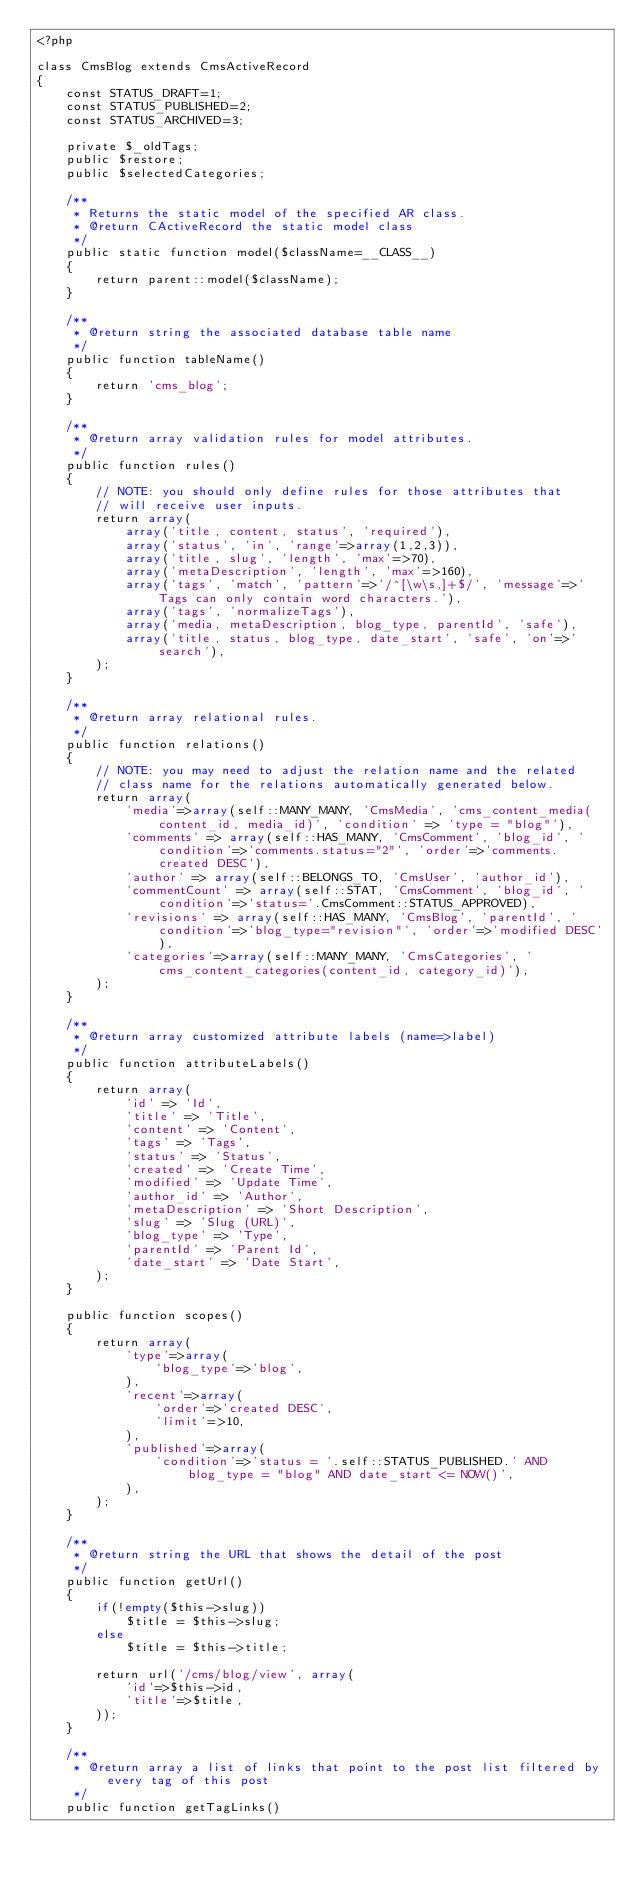<code> <loc_0><loc_0><loc_500><loc_500><_PHP_><?php

class CmsBlog extends CmsActiveRecord
{
	const STATUS_DRAFT=1;
	const STATUS_PUBLISHED=2;
	const STATUS_ARCHIVED=3;

	private $_oldTags;
	public $restore;
	public $selectedCategories;

	/**
	 * Returns the static model of the specified AR class.
	 * @return CActiveRecord the static model class
	 */
	public static function model($className=__CLASS__)
	{
		return parent::model($className);
	}

	/**
	 * @return string the associated database table name
	 */
	public function tableName()
	{
		return 'cms_blog';
	}

	/**
	 * @return array validation rules for model attributes.
	 */
	public function rules()
	{
		// NOTE: you should only define rules for those attributes that
		// will receive user inputs.
		return array(
			array('title, content, status', 'required'),
			array('status', 'in', 'range'=>array(1,2,3)),
			array('title, slug', 'length', 'max'=>70),
			array('metaDescription', 'length', 'max'=>160),
			array('tags', 'match', 'pattern'=>'/^[\w\s,]+$/', 'message'=>'Tags can only contain word characters.'),
			array('tags', 'normalizeTags'),
			array('media, metaDescription, blog_type, parentId', 'safe'), 
			array('title, status, blog_type, date_start', 'safe', 'on'=>'search'),
		);
	}

	/**
	 * @return array relational rules.
	 */
	public function relations()
	{
		// NOTE: you may need to adjust the relation name and the related
		// class name for the relations automatically generated below.
		return array(
			'media'=>array(self::MANY_MANY, 'CmsMedia', 'cms_content_media(content_id, media_id)', 'condition' => 'type = "blog"'),
			'comments' => array(self::HAS_MANY, 'CmsComment', 'blog_id', 'condition'=>'comments.status="2"', 'order'=>'comments.created DESC'),
			'author' => array(self::BELONGS_TO, 'CmsUser', 'author_id'),
			'commentCount' => array(self::STAT, 'CmsComment', 'blog_id', 'condition'=>'status='.CmsComment::STATUS_APPROVED),
			'revisions' => array(self::HAS_MANY, 'CmsBlog', 'parentId', 'condition'=>'blog_type="revision"', 'order'=>'modified DESC'),
			'categories'=>array(self::MANY_MANY, 'CmsCategories', 'cms_content_categories(content_id, category_id)'),
		);
	}

	/**
	 * @return array customized attribute labels (name=>label)
	 */
	public function attributeLabels()
	{
		return array(
			'id' => 'Id',
			'title' => 'Title',
			'content' => 'Content',
			'tags' => 'Tags',
			'status' => 'Status',
			'created' => 'Create Time',
			'modified' => 'Update Time',
			'author_id' => 'Author',
			'metaDescription' => 'Short Description',
			'slug' => 'Slug (URL)',
			'blog_type' => 'Type',
			'parentId' => 'Parent Id',
			'date_start' => 'Date Start',
		);
	}
	
	public function scopes()
    {
        return array(
        	'type'=>array(
        		'blog_type'=>'blog',
        	),
            'recent'=>array(
                'order'=>'created DESC',
                'limit'=>10,
            ),
            'published'=>array(
            	'condition'=>'status = '.self::STATUS_PUBLISHED.' AND blog_type = "blog" AND date_start <= NOW()',
            ),
        );
    }

	/**
	 * @return string the URL that shows the detail of the post
	 */
	public function getUrl()
	{
		if(!empty($this->slug))
			$title = $this->slug;
		else
			$title = $this->title;
		
		return url('/cms/blog/view', array(
			'id'=>$this->id,
			'title'=>$title,
		));
	}

	/**
	 * @return array a list of links that point to the post list filtered by every tag of this post
	 */
	public function getTagLinks()</code> 